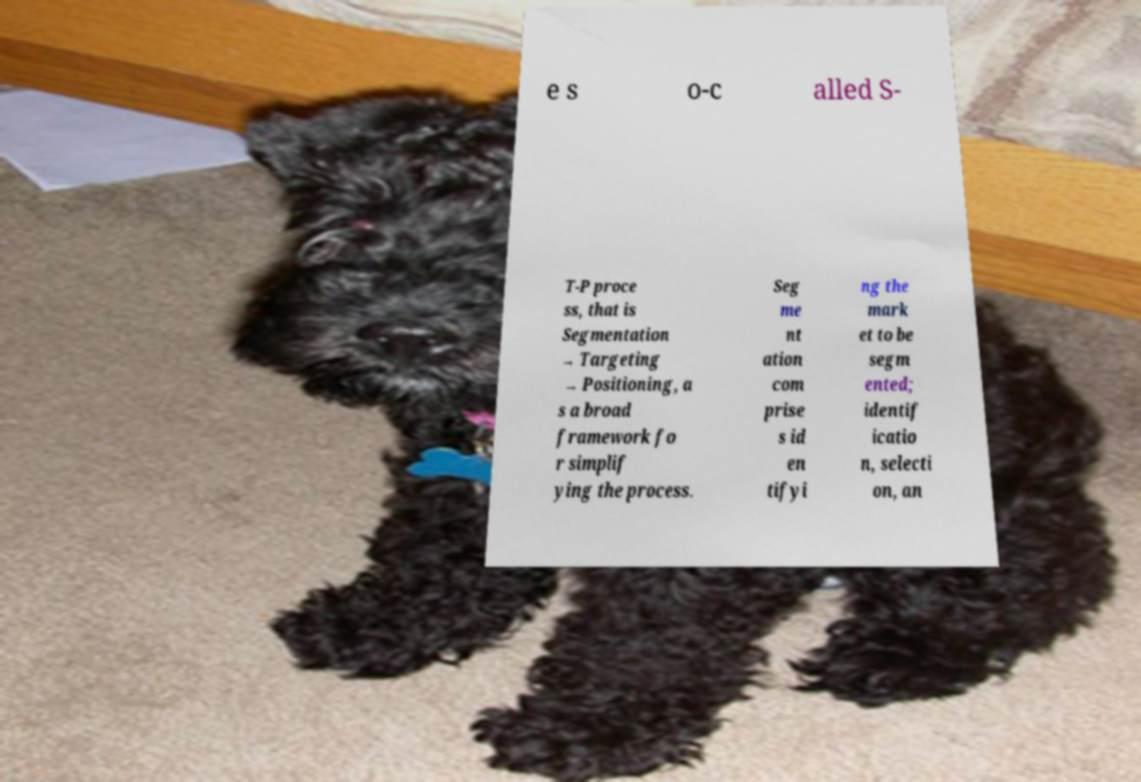Can you accurately transcribe the text from the provided image for me? e s o-c alled S- T-P proce ss, that is Segmentation → Targeting → Positioning, a s a broad framework fo r simplif ying the process. Seg me nt ation com prise s id en tifyi ng the mark et to be segm ented; identif icatio n, selecti on, an 